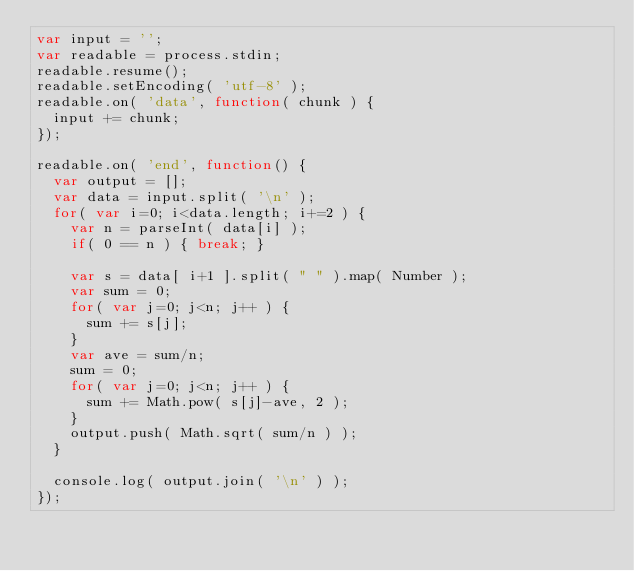<code> <loc_0><loc_0><loc_500><loc_500><_JavaScript_>var input = '';
var readable = process.stdin;
readable.resume();
readable.setEncoding( 'utf-8' );
readable.on( 'data', function( chunk ) {
  input += chunk;
});

readable.on( 'end', function() {
  var output = [];
  var data = input.split( '\n' );
  for( var i=0; i<data.length; i+=2 ) {
    var n = parseInt( data[i] );
    if( 0 == n ) { break; }
    
    var s = data[ i+1 ].split( " " ).map( Number );
    var sum = 0;
    for( var j=0; j<n; j++ ) {
      sum += s[j];
    }
    var ave = sum/n;
    sum = 0;
    for( var j=0; j<n; j++ ) {
      sum += Math.pow( s[j]-ave, 2 );
    }
    output.push( Math.sqrt( sum/n ) );
  }
    
  console.log( output.join( '\n' ) );
});</code> 